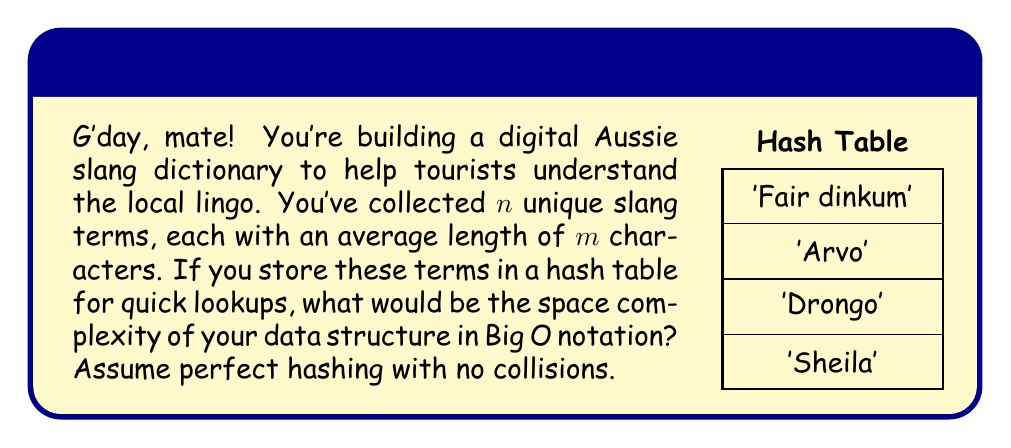Teach me how to tackle this problem. Let's approach this step-by-step:

1) We have $n$ unique slang terms, each with an average length of $m$ characters.

2) In a hash table, we need to store:
   a) The keys (slang terms)
   b) The values (definitions or explanations)

3) For the keys:
   - Each term requires $m$ characters on average
   - There are $n$ terms
   - So, the space for keys is $O(nm)$

4) For the values:
   - We don't have information about the length of definitions
   - But we know there's one definition per term
   - So, we can represent this as $O(n)$ multiplied by some constant factor

5) The hash table itself needs an array of size $n$ to store the $n$ entries (perfect hashing)

6) Combining these:
   Total space = Space for keys + Space for values + Hash table array
                = $O(nm) + O(n) + O(n)$
                = $O(nm + n)$

7) Since $m$ is typically much smaller than $n$, and we're looking for the worst-case scenario, we can simplify this to $O(nm)$

Therefore, the space complexity of the hash table storing Australian slang terms is $O(nm)$.
Answer: $O(nm)$ 